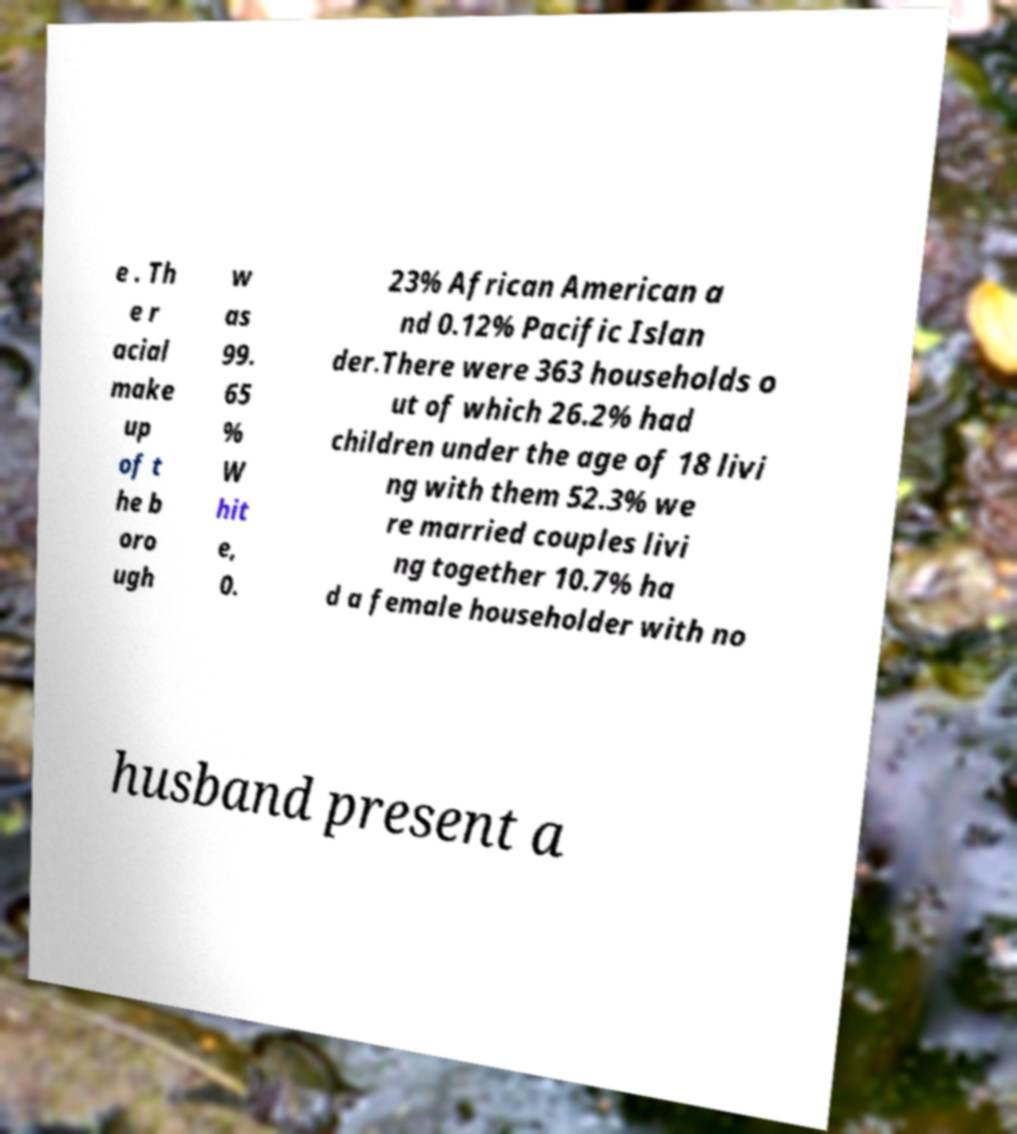Could you assist in decoding the text presented in this image and type it out clearly? e . Th e r acial make up of t he b oro ugh w as 99. 65 % W hit e, 0. 23% African American a nd 0.12% Pacific Islan der.There were 363 households o ut of which 26.2% had children under the age of 18 livi ng with them 52.3% we re married couples livi ng together 10.7% ha d a female householder with no husband present a 